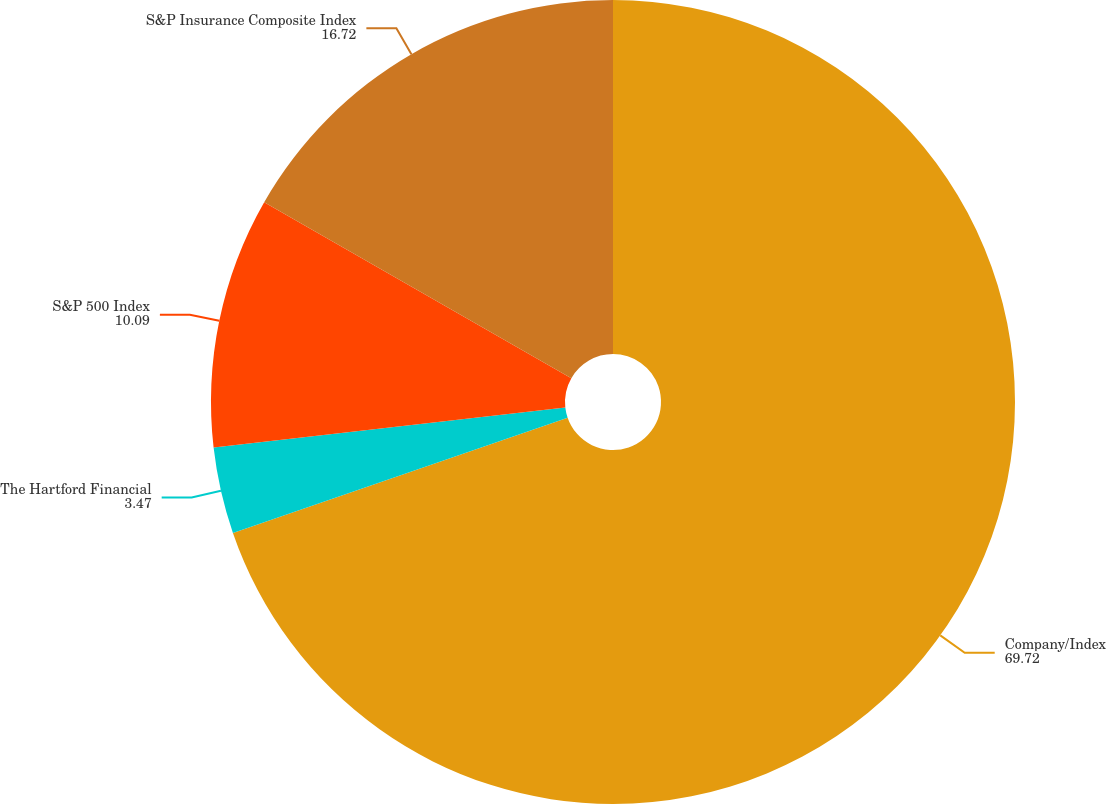Convert chart. <chart><loc_0><loc_0><loc_500><loc_500><pie_chart><fcel>Company/Index<fcel>The Hartford Financial<fcel>S&P 500 Index<fcel>S&P Insurance Composite Index<nl><fcel>69.72%<fcel>3.47%<fcel>10.09%<fcel>16.72%<nl></chart> 